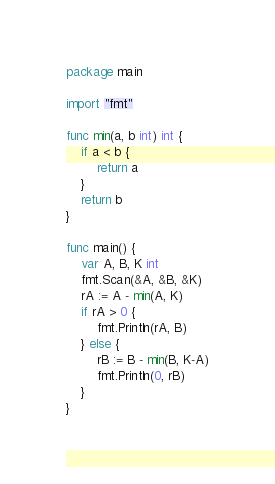Convert code to text. <code><loc_0><loc_0><loc_500><loc_500><_Go_>package main

import "fmt"

func min(a, b int) int {
	if a < b {
		return a
	}
	return b
}

func main() {
	var A, B, K int
	fmt.Scan(&A, &B, &K)
	rA := A - min(A, K)
	if rA > 0 {
		fmt.Println(rA, B)
	} else {
		rB := B - min(B, K-A)
		fmt.Println(0, rB)
	}
}
</code> 